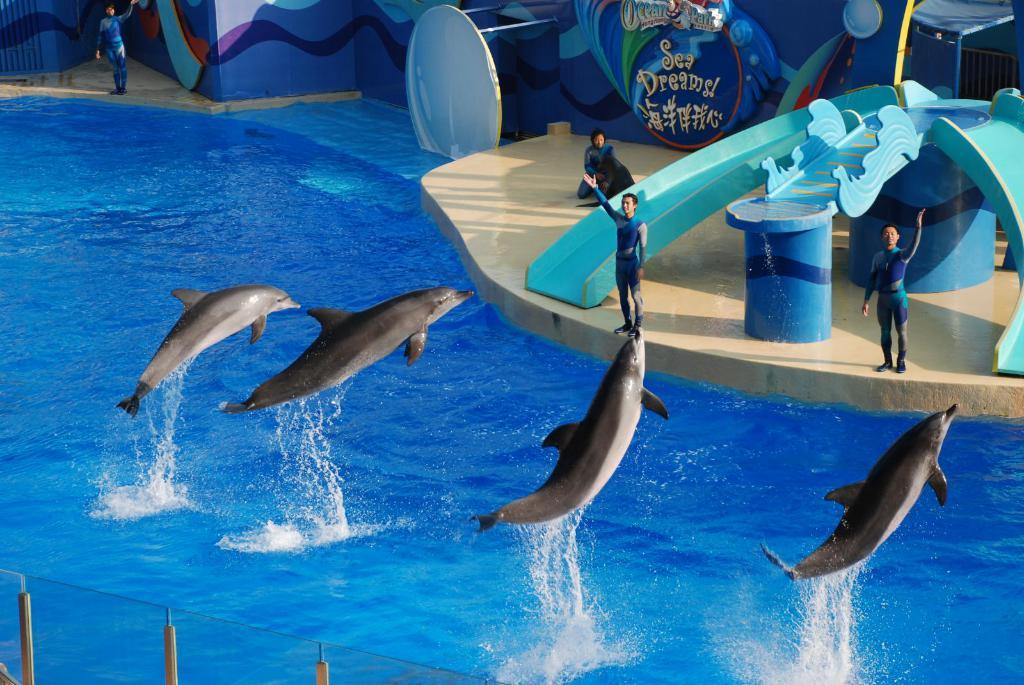What animals can be seen in the water in the image? There are dolphins in the water in the image. What are the people in the image doing? There are persons standing in the image. What can be seen on the wall in the image? There is text written on a wall in the image. What object is located in the front of the image? There is a glass in the front of the image. How many icicles are hanging from the glass in the image? There are no icicles present in the image; it features dolphins in the water, persons standing, text on a wall, and a glass. What type of dust can be seen on the dolphins in the image? There is no dust present on the dolphins in the image; they are in the water. 